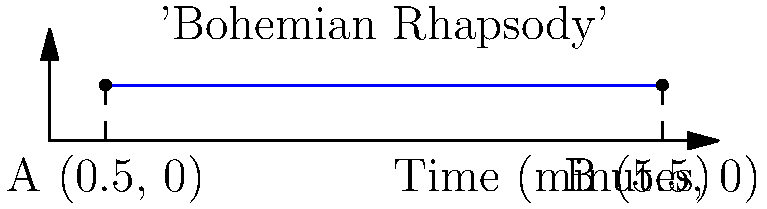The line segment AB in the graph represents the duration of Queen's iconic song "Bohemian Rhapsody". If point A is at (0.5, 0) and point B is at (5.5, 0), what are the coordinates of the midpoint of this line segment? This midpoint represents the exact middle of the song's duration. To find the midpoint of a line segment, we use the midpoint formula:

$$ \text{Midpoint} = \left(\frac{x_1 + x_2}{2}, \frac{y_1 + y_2}{2}\right) $$

Where $(x_1, y_1)$ are the coordinates of the first point and $(x_2, y_2)$ are the coordinates of the second point.

Given:
- Point A: (0.5, 0)
- Point B: (5.5, 0)

Step 1: Calculate the x-coordinate of the midpoint:
$$ x = \frac{x_1 + x_2}{2} = \frac{0.5 + 5.5}{2} = \frac{6}{2} = 3 $$

Step 2: Calculate the y-coordinate of the midpoint:
$$ y = \frac{y_1 + y_2}{2} = \frac{0 + 0}{2} = 0 $$

Therefore, the midpoint coordinates are (3, 0).

Fun fact: This means that at exactly 3 minutes into "Bohemian Rhapsody", you're at the midpoint of this epic 5:55 long masterpiece!
Answer: (3, 0) 